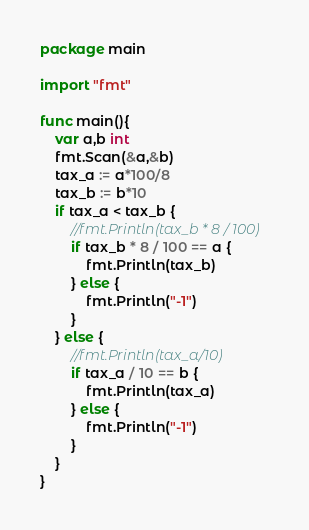Convert code to text. <code><loc_0><loc_0><loc_500><loc_500><_Go_>package main

import "fmt"

func main(){
	var a,b int
	fmt.Scan(&a,&b)
	tax_a := a*100/8
	tax_b := b*10
	if tax_a < tax_b {
		//fmt.Println(tax_b * 8 / 100)
		if tax_b * 8 / 100 == a {
			fmt.Println(tax_b)
		} else {
			fmt.Println("-1")
		}
	} else {
		//fmt.Println(tax_a/10)
		if tax_a / 10 == b {
			fmt.Println(tax_a)
		} else {
			fmt.Println("-1")
		}
	}
}
</code> 